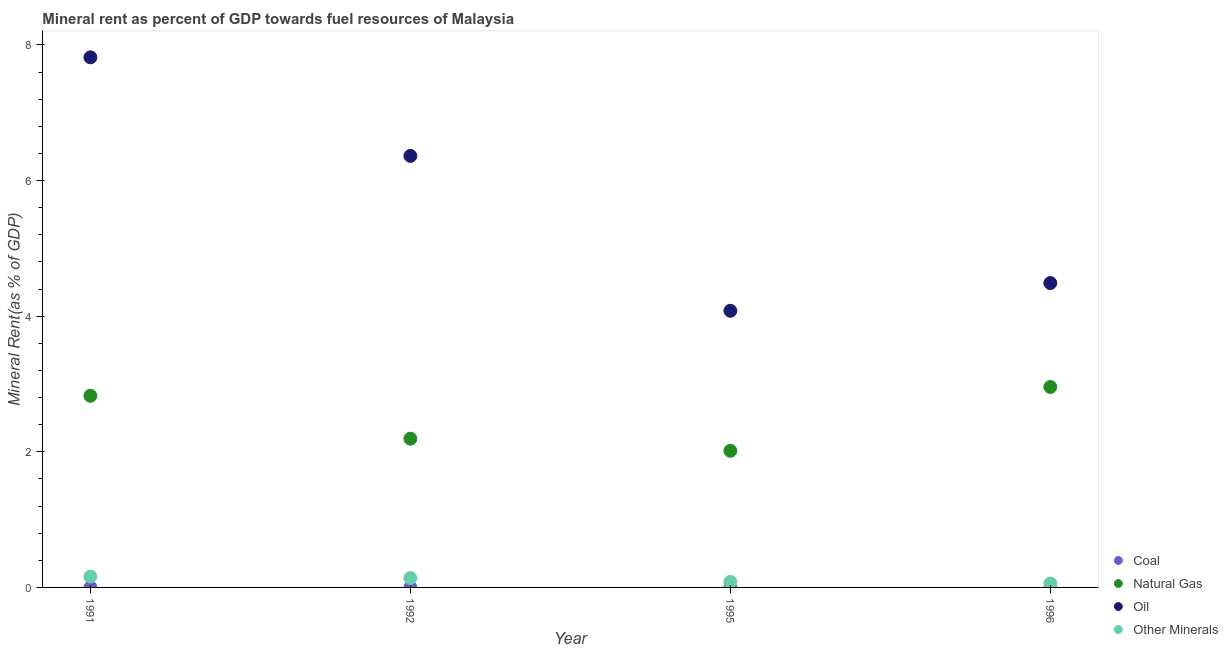Is the number of dotlines equal to the number of legend labels?
Give a very brief answer. Yes. What is the natural gas rent in 1991?
Your answer should be very brief. 2.83. Across all years, what is the maximum  rent of other minerals?
Provide a succinct answer. 0.16. Across all years, what is the minimum coal rent?
Your response must be concise. 8.374194379820171e-5. What is the total  rent of other minerals in the graph?
Make the answer very short. 0.44. What is the difference between the oil rent in 1991 and that in 1992?
Keep it short and to the point. 1.45. What is the difference between the  rent of other minerals in 1996 and the natural gas rent in 1995?
Offer a very short reply. -1.96. What is the average oil rent per year?
Ensure brevity in your answer.  5.69. In the year 1996, what is the difference between the oil rent and natural gas rent?
Keep it short and to the point. 1.53. In how many years, is the  rent of other minerals greater than 0.8 %?
Your answer should be very brief. 0. What is the ratio of the coal rent in 1995 to that in 1996?
Your answer should be compact. 1.78. What is the difference between the highest and the second highest  rent of other minerals?
Give a very brief answer. 0.02. What is the difference between the highest and the lowest natural gas rent?
Your response must be concise. 0.94. In how many years, is the  rent of other minerals greater than the average  rent of other minerals taken over all years?
Your answer should be very brief. 2. Is it the case that in every year, the sum of the natural gas rent and  rent of other minerals is greater than the sum of oil rent and coal rent?
Provide a short and direct response. No. Is the oil rent strictly greater than the  rent of other minerals over the years?
Keep it short and to the point. Yes. Is the natural gas rent strictly less than the coal rent over the years?
Make the answer very short. No. How many dotlines are there?
Your response must be concise. 4. How many years are there in the graph?
Make the answer very short. 4. What is the difference between two consecutive major ticks on the Y-axis?
Offer a very short reply. 2. Are the values on the major ticks of Y-axis written in scientific E-notation?
Make the answer very short. No. Does the graph contain grids?
Give a very brief answer. No. Where does the legend appear in the graph?
Your answer should be compact. Bottom right. How are the legend labels stacked?
Keep it short and to the point. Vertical. What is the title of the graph?
Make the answer very short. Mineral rent as percent of GDP towards fuel resources of Malaysia. Does "Norway" appear as one of the legend labels in the graph?
Keep it short and to the point. No. What is the label or title of the X-axis?
Provide a succinct answer. Year. What is the label or title of the Y-axis?
Offer a terse response. Mineral Rent(as % of GDP). What is the Mineral Rent(as % of GDP) in Coal in 1991?
Provide a short and direct response. 0. What is the Mineral Rent(as % of GDP) of Natural Gas in 1991?
Offer a terse response. 2.83. What is the Mineral Rent(as % of GDP) of Oil in 1991?
Offer a terse response. 7.82. What is the Mineral Rent(as % of GDP) in Other Minerals in 1991?
Provide a succinct answer. 0.16. What is the Mineral Rent(as % of GDP) in Coal in 1992?
Give a very brief answer. 0. What is the Mineral Rent(as % of GDP) of Natural Gas in 1992?
Your response must be concise. 2.19. What is the Mineral Rent(as % of GDP) in Oil in 1992?
Keep it short and to the point. 6.36. What is the Mineral Rent(as % of GDP) of Other Minerals in 1992?
Keep it short and to the point. 0.14. What is the Mineral Rent(as % of GDP) in Coal in 1995?
Offer a terse response. 0. What is the Mineral Rent(as % of GDP) of Natural Gas in 1995?
Your answer should be very brief. 2.01. What is the Mineral Rent(as % of GDP) of Oil in 1995?
Give a very brief answer. 4.08. What is the Mineral Rent(as % of GDP) in Other Minerals in 1995?
Give a very brief answer. 0.08. What is the Mineral Rent(as % of GDP) of Coal in 1996?
Your answer should be very brief. 8.374194379820171e-5. What is the Mineral Rent(as % of GDP) of Natural Gas in 1996?
Ensure brevity in your answer.  2.96. What is the Mineral Rent(as % of GDP) of Oil in 1996?
Your answer should be very brief. 4.49. What is the Mineral Rent(as % of GDP) of Other Minerals in 1996?
Your answer should be very brief. 0.06. Across all years, what is the maximum Mineral Rent(as % of GDP) of Coal?
Make the answer very short. 0. Across all years, what is the maximum Mineral Rent(as % of GDP) of Natural Gas?
Ensure brevity in your answer.  2.96. Across all years, what is the maximum Mineral Rent(as % of GDP) of Oil?
Make the answer very short. 7.82. Across all years, what is the maximum Mineral Rent(as % of GDP) in Other Minerals?
Make the answer very short. 0.16. Across all years, what is the minimum Mineral Rent(as % of GDP) of Coal?
Keep it short and to the point. 8.374194379820171e-5. Across all years, what is the minimum Mineral Rent(as % of GDP) in Natural Gas?
Provide a succinct answer. 2.01. Across all years, what is the minimum Mineral Rent(as % of GDP) in Oil?
Ensure brevity in your answer.  4.08. Across all years, what is the minimum Mineral Rent(as % of GDP) in Other Minerals?
Provide a succinct answer. 0.06. What is the total Mineral Rent(as % of GDP) in Coal in the graph?
Ensure brevity in your answer.  0. What is the total Mineral Rent(as % of GDP) in Natural Gas in the graph?
Offer a very short reply. 9.99. What is the total Mineral Rent(as % of GDP) of Oil in the graph?
Offer a very short reply. 22.75. What is the total Mineral Rent(as % of GDP) of Other Minerals in the graph?
Your answer should be compact. 0.44. What is the difference between the Mineral Rent(as % of GDP) in Coal in 1991 and that in 1992?
Ensure brevity in your answer.  0. What is the difference between the Mineral Rent(as % of GDP) in Natural Gas in 1991 and that in 1992?
Offer a terse response. 0.63. What is the difference between the Mineral Rent(as % of GDP) in Oil in 1991 and that in 1992?
Your answer should be compact. 1.45. What is the difference between the Mineral Rent(as % of GDP) in Other Minerals in 1991 and that in 1992?
Ensure brevity in your answer.  0.02. What is the difference between the Mineral Rent(as % of GDP) of Natural Gas in 1991 and that in 1995?
Your answer should be very brief. 0.81. What is the difference between the Mineral Rent(as % of GDP) in Oil in 1991 and that in 1995?
Your answer should be compact. 3.74. What is the difference between the Mineral Rent(as % of GDP) of Other Minerals in 1991 and that in 1995?
Your response must be concise. 0.08. What is the difference between the Mineral Rent(as % of GDP) of Coal in 1991 and that in 1996?
Offer a terse response. 0. What is the difference between the Mineral Rent(as % of GDP) of Natural Gas in 1991 and that in 1996?
Provide a succinct answer. -0.13. What is the difference between the Mineral Rent(as % of GDP) of Oil in 1991 and that in 1996?
Your answer should be very brief. 3.33. What is the difference between the Mineral Rent(as % of GDP) of Other Minerals in 1991 and that in 1996?
Offer a very short reply. 0.1. What is the difference between the Mineral Rent(as % of GDP) in Natural Gas in 1992 and that in 1995?
Offer a very short reply. 0.18. What is the difference between the Mineral Rent(as % of GDP) of Oil in 1992 and that in 1995?
Make the answer very short. 2.28. What is the difference between the Mineral Rent(as % of GDP) in Other Minerals in 1992 and that in 1995?
Offer a terse response. 0.06. What is the difference between the Mineral Rent(as % of GDP) of Natural Gas in 1992 and that in 1996?
Your answer should be very brief. -0.76. What is the difference between the Mineral Rent(as % of GDP) in Oil in 1992 and that in 1996?
Provide a succinct answer. 1.88. What is the difference between the Mineral Rent(as % of GDP) in Other Minerals in 1992 and that in 1996?
Keep it short and to the point. 0.08. What is the difference between the Mineral Rent(as % of GDP) in Natural Gas in 1995 and that in 1996?
Your answer should be very brief. -0.94. What is the difference between the Mineral Rent(as % of GDP) of Oil in 1995 and that in 1996?
Offer a very short reply. -0.41. What is the difference between the Mineral Rent(as % of GDP) in Other Minerals in 1995 and that in 1996?
Provide a succinct answer. 0.02. What is the difference between the Mineral Rent(as % of GDP) of Coal in 1991 and the Mineral Rent(as % of GDP) of Natural Gas in 1992?
Offer a terse response. -2.19. What is the difference between the Mineral Rent(as % of GDP) in Coal in 1991 and the Mineral Rent(as % of GDP) in Oil in 1992?
Ensure brevity in your answer.  -6.36. What is the difference between the Mineral Rent(as % of GDP) of Coal in 1991 and the Mineral Rent(as % of GDP) of Other Minerals in 1992?
Your answer should be compact. -0.14. What is the difference between the Mineral Rent(as % of GDP) of Natural Gas in 1991 and the Mineral Rent(as % of GDP) of Oil in 1992?
Make the answer very short. -3.54. What is the difference between the Mineral Rent(as % of GDP) in Natural Gas in 1991 and the Mineral Rent(as % of GDP) in Other Minerals in 1992?
Make the answer very short. 2.69. What is the difference between the Mineral Rent(as % of GDP) of Oil in 1991 and the Mineral Rent(as % of GDP) of Other Minerals in 1992?
Your answer should be compact. 7.68. What is the difference between the Mineral Rent(as % of GDP) of Coal in 1991 and the Mineral Rent(as % of GDP) of Natural Gas in 1995?
Provide a succinct answer. -2.01. What is the difference between the Mineral Rent(as % of GDP) in Coal in 1991 and the Mineral Rent(as % of GDP) in Oil in 1995?
Your answer should be compact. -4.08. What is the difference between the Mineral Rent(as % of GDP) in Coal in 1991 and the Mineral Rent(as % of GDP) in Other Minerals in 1995?
Your answer should be very brief. -0.08. What is the difference between the Mineral Rent(as % of GDP) of Natural Gas in 1991 and the Mineral Rent(as % of GDP) of Oil in 1995?
Your response must be concise. -1.25. What is the difference between the Mineral Rent(as % of GDP) in Natural Gas in 1991 and the Mineral Rent(as % of GDP) in Other Minerals in 1995?
Offer a terse response. 2.74. What is the difference between the Mineral Rent(as % of GDP) in Oil in 1991 and the Mineral Rent(as % of GDP) in Other Minerals in 1995?
Make the answer very short. 7.74. What is the difference between the Mineral Rent(as % of GDP) in Coal in 1991 and the Mineral Rent(as % of GDP) in Natural Gas in 1996?
Provide a short and direct response. -2.96. What is the difference between the Mineral Rent(as % of GDP) in Coal in 1991 and the Mineral Rent(as % of GDP) in Oil in 1996?
Provide a short and direct response. -4.49. What is the difference between the Mineral Rent(as % of GDP) of Coal in 1991 and the Mineral Rent(as % of GDP) of Other Minerals in 1996?
Provide a succinct answer. -0.06. What is the difference between the Mineral Rent(as % of GDP) in Natural Gas in 1991 and the Mineral Rent(as % of GDP) in Oil in 1996?
Keep it short and to the point. -1.66. What is the difference between the Mineral Rent(as % of GDP) in Natural Gas in 1991 and the Mineral Rent(as % of GDP) in Other Minerals in 1996?
Make the answer very short. 2.77. What is the difference between the Mineral Rent(as % of GDP) of Oil in 1991 and the Mineral Rent(as % of GDP) of Other Minerals in 1996?
Your response must be concise. 7.76. What is the difference between the Mineral Rent(as % of GDP) of Coal in 1992 and the Mineral Rent(as % of GDP) of Natural Gas in 1995?
Offer a terse response. -2.01. What is the difference between the Mineral Rent(as % of GDP) in Coal in 1992 and the Mineral Rent(as % of GDP) in Oil in 1995?
Give a very brief answer. -4.08. What is the difference between the Mineral Rent(as % of GDP) in Coal in 1992 and the Mineral Rent(as % of GDP) in Other Minerals in 1995?
Your answer should be compact. -0.08. What is the difference between the Mineral Rent(as % of GDP) of Natural Gas in 1992 and the Mineral Rent(as % of GDP) of Oil in 1995?
Give a very brief answer. -1.89. What is the difference between the Mineral Rent(as % of GDP) in Natural Gas in 1992 and the Mineral Rent(as % of GDP) in Other Minerals in 1995?
Ensure brevity in your answer.  2.11. What is the difference between the Mineral Rent(as % of GDP) of Oil in 1992 and the Mineral Rent(as % of GDP) of Other Minerals in 1995?
Offer a terse response. 6.28. What is the difference between the Mineral Rent(as % of GDP) in Coal in 1992 and the Mineral Rent(as % of GDP) in Natural Gas in 1996?
Keep it short and to the point. -2.96. What is the difference between the Mineral Rent(as % of GDP) in Coal in 1992 and the Mineral Rent(as % of GDP) in Oil in 1996?
Give a very brief answer. -4.49. What is the difference between the Mineral Rent(as % of GDP) of Coal in 1992 and the Mineral Rent(as % of GDP) of Other Minerals in 1996?
Keep it short and to the point. -0.06. What is the difference between the Mineral Rent(as % of GDP) of Natural Gas in 1992 and the Mineral Rent(as % of GDP) of Oil in 1996?
Provide a short and direct response. -2.29. What is the difference between the Mineral Rent(as % of GDP) in Natural Gas in 1992 and the Mineral Rent(as % of GDP) in Other Minerals in 1996?
Keep it short and to the point. 2.14. What is the difference between the Mineral Rent(as % of GDP) in Oil in 1992 and the Mineral Rent(as % of GDP) in Other Minerals in 1996?
Keep it short and to the point. 6.31. What is the difference between the Mineral Rent(as % of GDP) in Coal in 1995 and the Mineral Rent(as % of GDP) in Natural Gas in 1996?
Your answer should be compact. -2.96. What is the difference between the Mineral Rent(as % of GDP) of Coal in 1995 and the Mineral Rent(as % of GDP) of Oil in 1996?
Keep it short and to the point. -4.49. What is the difference between the Mineral Rent(as % of GDP) in Coal in 1995 and the Mineral Rent(as % of GDP) in Other Minerals in 1996?
Your answer should be compact. -0.06. What is the difference between the Mineral Rent(as % of GDP) in Natural Gas in 1995 and the Mineral Rent(as % of GDP) in Oil in 1996?
Your response must be concise. -2.47. What is the difference between the Mineral Rent(as % of GDP) in Natural Gas in 1995 and the Mineral Rent(as % of GDP) in Other Minerals in 1996?
Your response must be concise. 1.96. What is the difference between the Mineral Rent(as % of GDP) of Oil in 1995 and the Mineral Rent(as % of GDP) of Other Minerals in 1996?
Provide a short and direct response. 4.02. What is the average Mineral Rent(as % of GDP) of Coal per year?
Offer a terse response. 0. What is the average Mineral Rent(as % of GDP) in Natural Gas per year?
Your response must be concise. 2.5. What is the average Mineral Rent(as % of GDP) of Oil per year?
Provide a succinct answer. 5.69. What is the average Mineral Rent(as % of GDP) in Other Minerals per year?
Make the answer very short. 0.11. In the year 1991, what is the difference between the Mineral Rent(as % of GDP) in Coal and Mineral Rent(as % of GDP) in Natural Gas?
Your response must be concise. -2.83. In the year 1991, what is the difference between the Mineral Rent(as % of GDP) of Coal and Mineral Rent(as % of GDP) of Oil?
Offer a very short reply. -7.82. In the year 1991, what is the difference between the Mineral Rent(as % of GDP) in Coal and Mineral Rent(as % of GDP) in Other Minerals?
Your answer should be very brief. -0.16. In the year 1991, what is the difference between the Mineral Rent(as % of GDP) in Natural Gas and Mineral Rent(as % of GDP) in Oil?
Offer a very short reply. -4.99. In the year 1991, what is the difference between the Mineral Rent(as % of GDP) in Natural Gas and Mineral Rent(as % of GDP) in Other Minerals?
Make the answer very short. 2.67. In the year 1991, what is the difference between the Mineral Rent(as % of GDP) in Oil and Mineral Rent(as % of GDP) in Other Minerals?
Offer a very short reply. 7.66. In the year 1992, what is the difference between the Mineral Rent(as % of GDP) in Coal and Mineral Rent(as % of GDP) in Natural Gas?
Offer a terse response. -2.19. In the year 1992, what is the difference between the Mineral Rent(as % of GDP) in Coal and Mineral Rent(as % of GDP) in Oil?
Keep it short and to the point. -6.36. In the year 1992, what is the difference between the Mineral Rent(as % of GDP) in Coal and Mineral Rent(as % of GDP) in Other Minerals?
Make the answer very short. -0.14. In the year 1992, what is the difference between the Mineral Rent(as % of GDP) in Natural Gas and Mineral Rent(as % of GDP) in Oil?
Provide a short and direct response. -4.17. In the year 1992, what is the difference between the Mineral Rent(as % of GDP) of Natural Gas and Mineral Rent(as % of GDP) of Other Minerals?
Provide a short and direct response. 2.05. In the year 1992, what is the difference between the Mineral Rent(as % of GDP) in Oil and Mineral Rent(as % of GDP) in Other Minerals?
Ensure brevity in your answer.  6.22. In the year 1995, what is the difference between the Mineral Rent(as % of GDP) of Coal and Mineral Rent(as % of GDP) of Natural Gas?
Your response must be concise. -2.01. In the year 1995, what is the difference between the Mineral Rent(as % of GDP) in Coal and Mineral Rent(as % of GDP) in Oil?
Provide a short and direct response. -4.08. In the year 1995, what is the difference between the Mineral Rent(as % of GDP) of Coal and Mineral Rent(as % of GDP) of Other Minerals?
Ensure brevity in your answer.  -0.08. In the year 1995, what is the difference between the Mineral Rent(as % of GDP) of Natural Gas and Mineral Rent(as % of GDP) of Oil?
Keep it short and to the point. -2.06. In the year 1995, what is the difference between the Mineral Rent(as % of GDP) of Natural Gas and Mineral Rent(as % of GDP) of Other Minerals?
Provide a succinct answer. 1.93. In the year 1995, what is the difference between the Mineral Rent(as % of GDP) in Oil and Mineral Rent(as % of GDP) in Other Minerals?
Ensure brevity in your answer.  4. In the year 1996, what is the difference between the Mineral Rent(as % of GDP) in Coal and Mineral Rent(as % of GDP) in Natural Gas?
Keep it short and to the point. -2.96. In the year 1996, what is the difference between the Mineral Rent(as % of GDP) in Coal and Mineral Rent(as % of GDP) in Oil?
Provide a short and direct response. -4.49. In the year 1996, what is the difference between the Mineral Rent(as % of GDP) of Coal and Mineral Rent(as % of GDP) of Other Minerals?
Keep it short and to the point. -0.06. In the year 1996, what is the difference between the Mineral Rent(as % of GDP) of Natural Gas and Mineral Rent(as % of GDP) of Oil?
Your answer should be very brief. -1.53. In the year 1996, what is the difference between the Mineral Rent(as % of GDP) of Natural Gas and Mineral Rent(as % of GDP) of Other Minerals?
Provide a succinct answer. 2.9. In the year 1996, what is the difference between the Mineral Rent(as % of GDP) of Oil and Mineral Rent(as % of GDP) of Other Minerals?
Your answer should be very brief. 4.43. What is the ratio of the Mineral Rent(as % of GDP) of Coal in 1991 to that in 1992?
Provide a short and direct response. 4.73. What is the ratio of the Mineral Rent(as % of GDP) in Natural Gas in 1991 to that in 1992?
Keep it short and to the point. 1.29. What is the ratio of the Mineral Rent(as % of GDP) of Oil in 1991 to that in 1992?
Make the answer very short. 1.23. What is the ratio of the Mineral Rent(as % of GDP) in Other Minerals in 1991 to that in 1992?
Keep it short and to the point. 1.15. What is the ratio of the Mineral Rent(as % of GDP) of Coal in 1991 to that in 1995?
Provide a succinct answer. 8.05. What is the ratio of the Mineral Rent(as % of GDP) of Natural Gas in 1991 to that in 1995?
Keep it short and to the point. 1.4. What is the ratio of the Mineral Rent(as % of GDP) in Oil in 1991 to that in 1995?
Your answer should be very brief. 1.92. What is the ratio of the Mineral Rent(as % of GDP) of Other Minerals in 1991 to that in 1995?
Offer a very short reply. 1.95. What is the ratio of the Mineral Rent(as % of GDP) in Coal in 1991 to that in 1996?
Offer a terse response. 14.3. What is the ratio of the Mineral Rent(as % of GDP) in Natural Gas in 1991 to that in 1996?
Provide a succinct answer. 0.96. What is the ratio of the Mineral Rent(as % of GDP) of Oil in 1991 to that in 1996?
Give a very brief answer. 1.74. What is the ratio of the Mineral Rent(as % of GDP) in Other Minerals in 1991 to that in 1996?
Make the answer very short. 2.75. What is the ratio of the Mineral Rent(as % of GDP) in Coal in 1992 to that in 1995?
Your answer should be compact. 1.7. What is the ratio of the Mineral Rent(as % of GDP) in Natural Gas in 1992 to that in 1995?
Provide a short and direct response. 1.09. What is the ratio of the Mineral Rent(as % of GDP) in Oil in 1992 to that in 1995?
Make the answer very short. 1.56. What is the ratio of the Mineral Rent(as % of GDP) in Other Minerals in 1992 to that in 1995?
Keep it short and to the point. 1.69. What is the ratio of the Mineral Rent(as % of GDP) in Coal in 1992 to that in 1996?
Make the answer very short. 3.02. What is the ratio of the Mineral Rent(as % of GDP) of Natural Gas in 1992 to that in 1996?
Provide a short and direct response. 0.74. What is the ratio of the Mineral Rent(as % of GDP) of Oil in 1992 to that in 1996?
Give a very brief answer. 1.42. What is the ratio of the Mineral Rent(as % of GDP) in Other Minerals in 1992 to that in 1996?
Give a very brief answer. 2.38. What is the ratio of the Mineral Rent(as % of GDP) in Coal in 1995 to that in 1996?
Your answer should be compact. 1.78. What is the ratio of the Mineral Rent(as % of GDP) of Natural Gas in 1995 to that in 1996?
Your answer should be compact. 0.68. What is the ratio of the Mineral Rent(as % of GDP) in Oil in 1995 to that in 1996?
Your answer should be compact. 0.91. What is the ratio of the Mineral Rent(as % of GDP) in Other Minerals in 1995 to that in 1996?
Offer a terse response. 1.41. What is the difference between the highest and the second highest Mineral Rent(as % of GDP) of Coal?
Keep it short and to the point. 0. What is the difference between the highest and the second highest Mineral Rent(as % of GDP) of Natural Gas?
Offer a very short reply. 0.13. What is the difference between the highest and the second highest Mineral Rent(as % of GDP) of Oil?
Your answer should be compact. 1.45. What is the difference between the highest and the second highest Mineral Rent(as % of GDP) of Other Minerals?
Provide a succinct answer. 0.02. What is the difference between the highest and the lowest Mineral Rent(as % of GDP) in Coal?
Give a very brief answer. 0. What is the difference between the highest and the lowest Mineral Rent(as % of GDP) in Natural Gas?
Give a very brief answer. 0.94. What is the difference between the highest and the lowest Mineral Rent(as % of GDP) of Oil?
Provide a short and direct response. 3.74. What is the difference between the highest and the lowest Mineral Rent(as % of GDP) of Other Minerals?
Offer a terse response. 0.1. 